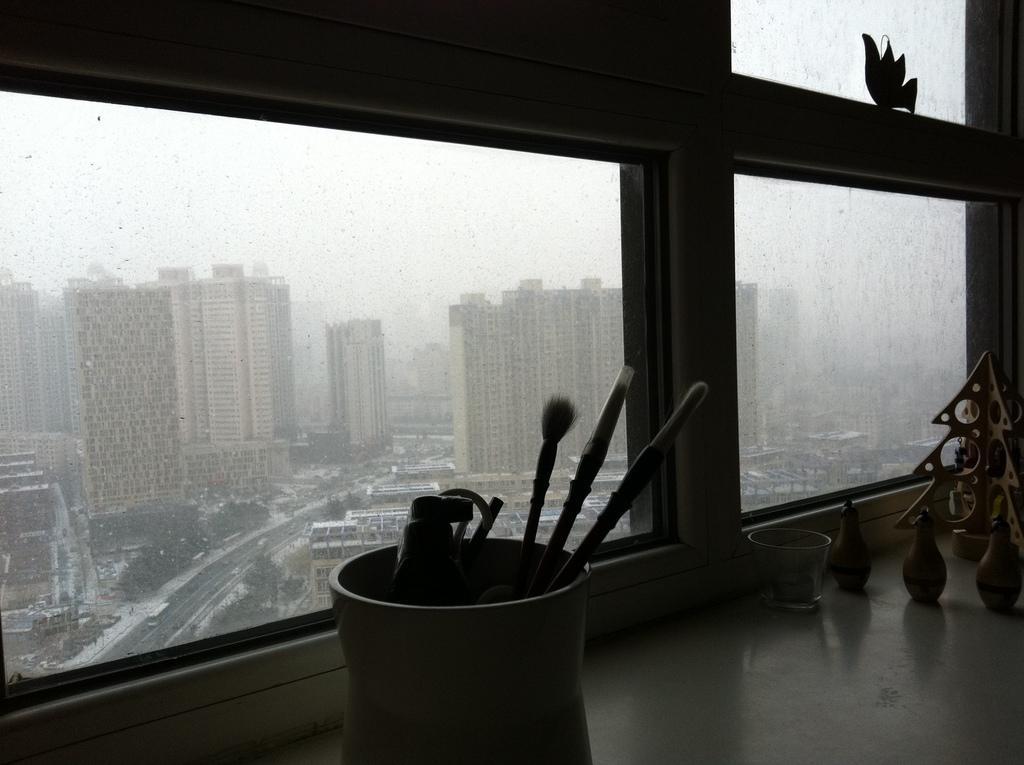In one or two sentences, can you explain what this image depicts? In this image we can see buildings, trees and the sky through the windows. At the right side of the image we can see some objects placed on the surface. At the bottom of the image we can see some brushes and object placed in a container. 